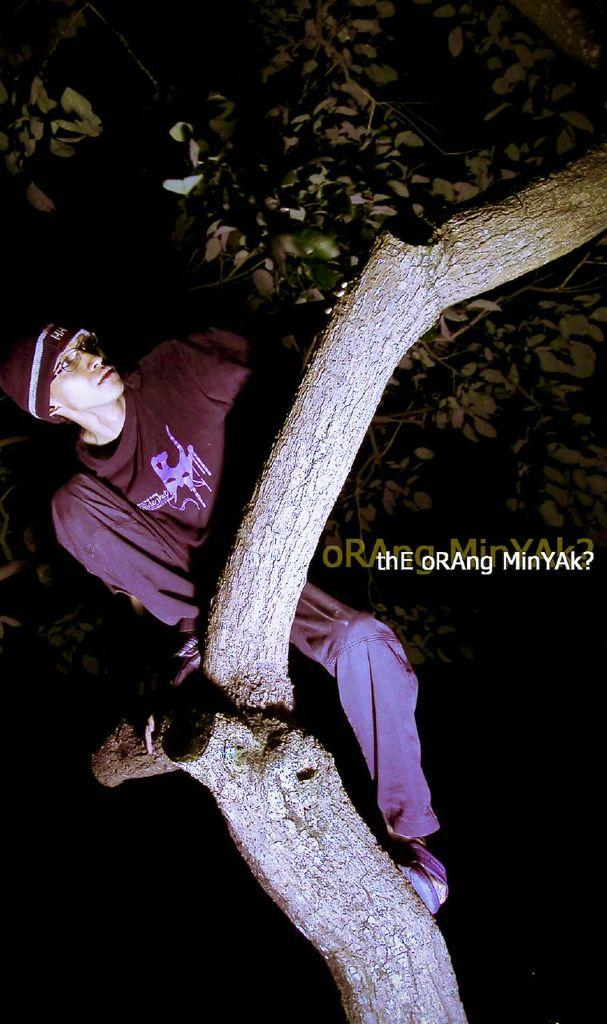What is the main object in the image? There is a tree in the image. What is the person in the image doing? A person is sitting on the tree. What can be seen on the right side of the image? There is some text on the right side of the image. How would you describe the overall lighting in the image? The background of the image is dark. What type of smoke can be seen coming from the industry in the image? There is no industry or smoke present in the image; it features a tree with a person sitting on it and some text on the right side. 